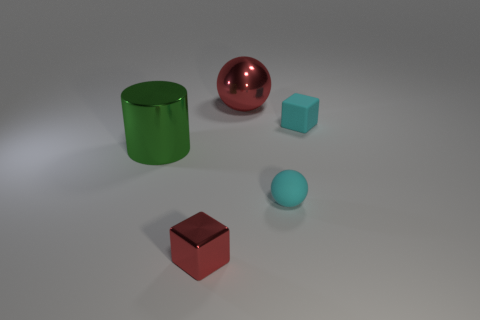Is there any other thing that is the same shape as the green object?
Offer a terse response. No. Are there fewer large red metal objects that are to the right of the red ball than red metallic things that are behind the red cube?
Ensure brevity in your answer.  Yes. Is the material of the green cylinder the same as the big red thing?
Ensure brevity in your answer.  Yes. There is a object that is behind the large green shiny cylinder and right of the large red shiny object; what size is it?
Offer a very short reply. Small. The red shiny object that is the same size as the green metallic cylinder is what shape?
Offer a very short reply. Sphere. What material is the red object that is to the right of the object in front of the cyan matte thing that is left of the cyan matte block made of?
Offer a terse response. Metal. Does the red object in front of the big red metallic object have the same shape as the thing that is to the left of the metallic cube?
Keep it short and to the point. No. How many other things are there of the same material as the cyan ball?
Provide a short and direct response. 1. Is the small object on the left side of the cyan sphere made of the same material as the big object left of the tiny red object?
Offer a terse response. Yes. The tiny thing that is the same material as the green cylinder is what shape?
Give a very brief answer. Cube. 